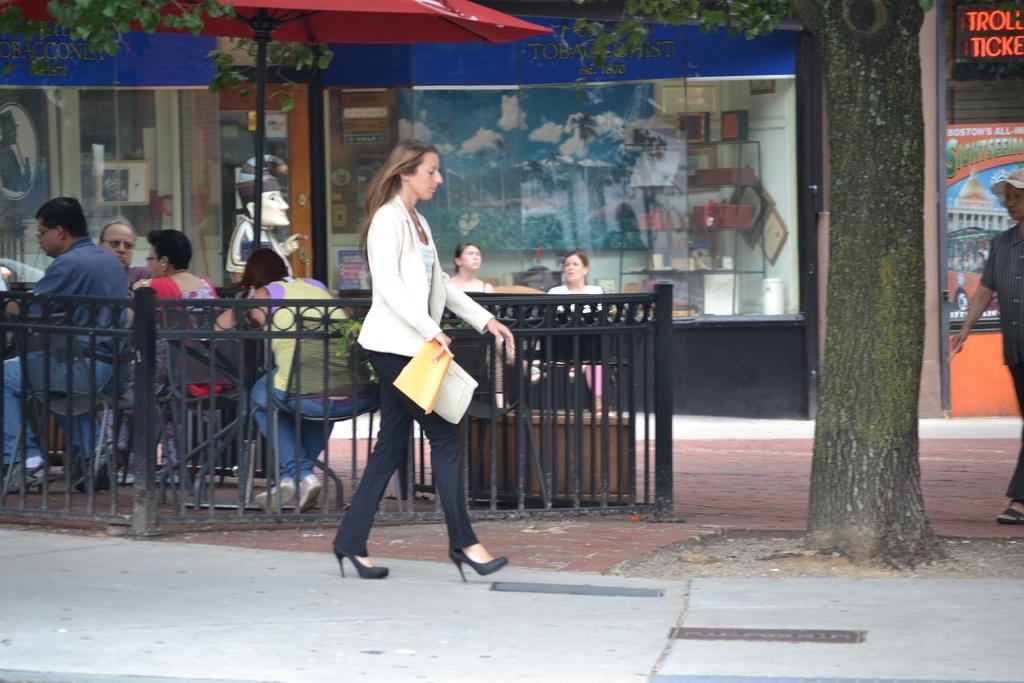Describe this image in one or two sentences. In this image, we can see people sitting on the chairs and some are walking on the road and one of them is wearing a cap and there is a lady holding an object. In the background, there is an umbrella and we can see a bin, trees and there are boards, railings and stores. 